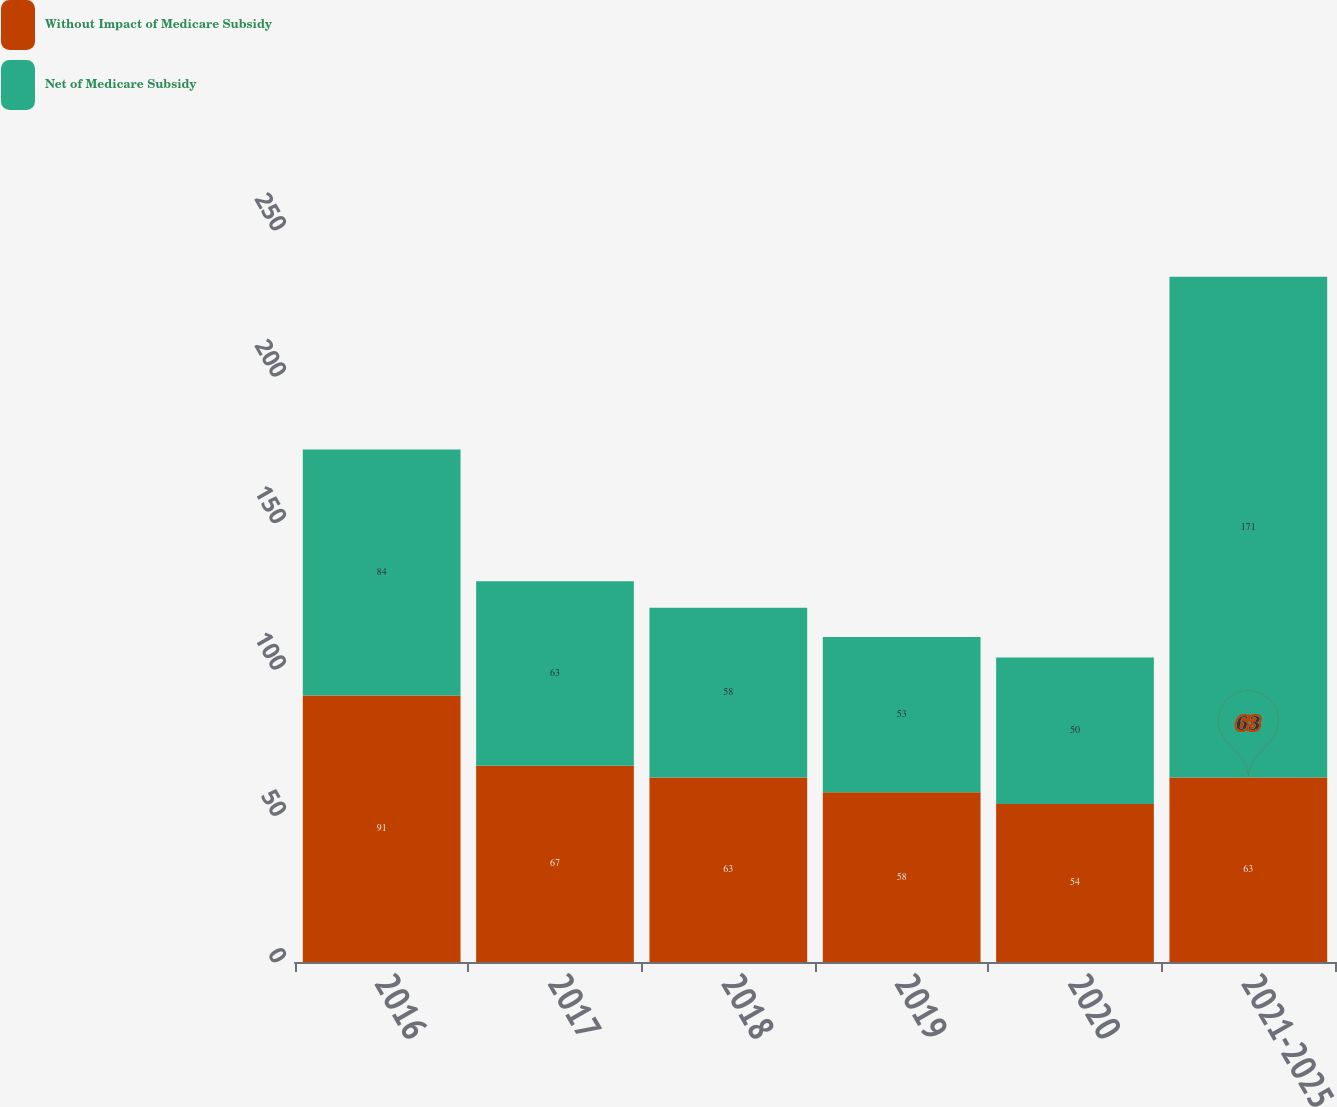<chart> <loc_0><loc_0><loc_500><loc_500><stacked_bar_chart><ecel><fcel>2016<fcel>2017<fcel>2018<fcel>2019<fcel>2020<fcel>2021-2025<nl><fcel>Without Impact of Medicare Subsidy<fcel>91<fcel>67<fcel>63<fcel>58<fcel>54<fcel>63<nl><fcel>Net of Medicare Subsidy<fcel>84<fcel>63<fcel>58<fcel>53<fcel>50<fcel>171<nl></chart> 